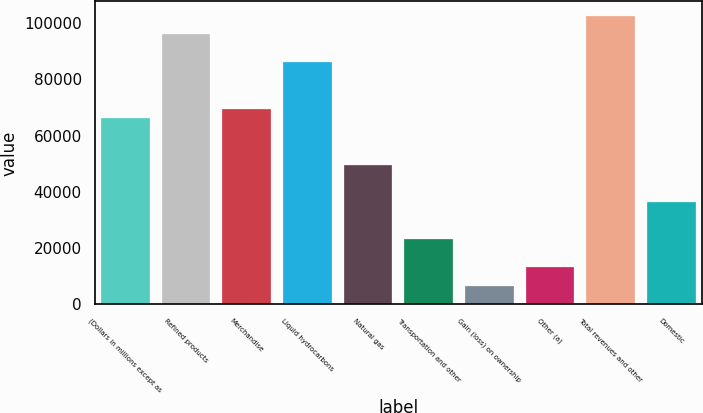<chart> <loc_0><loc_0><loc_500><loc_500><bar_chart><fcel>(Dollars in millions except as<fcel>Refined products<fcel>Merchandise<fcel>Liquid hydrocarbons<fcel>Natural gas<fcel>Transportation and other<fcel>Gain (loss) on ownership<fcel>Other (a)<fcel>Total revenues and other<fcel>Domestic<nl><fcel>66170<fcel>95945.6<fcel>69478.4<fcel>86020.4<fcel>49628<fcel>23160.8<fcel>6618.8<fcel>13235.6<fcel>102562<fcel>36394.4<nl></chart> 